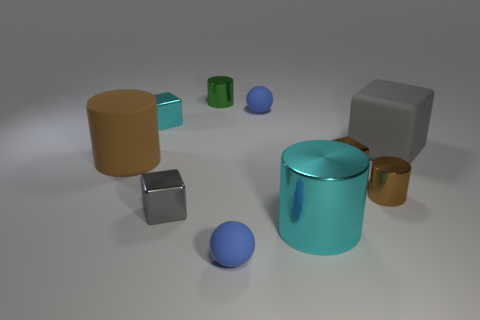What number of small metal cylinders have the same color as the big block?
Keep it short and to the point. 0. How many objects are tiny blue matte balls in front of the big brown matte thing or rubber balls that are in front of the big gray rubber cube?
Make the answer very short. 1. Are there fewer objects behind the big brown matte thing than cylinders?
Give a very brief answer. No. Is there a cyan block that has the same size as the brown block?
Your answer should be very brief. Yes. The large block has what color?
Ensure brevity in your answer.  Gray. Does the cyan cylinder have the same size as the cyan cube?
Provide a succinct answer. No. How many objects are large blocks or small metallic cylinders?
Your answer should be very brief. 3. Are there an equal number of small blue matte things that are left of the green metal thing and large red matte cubes?
Your answer should be compact. Yes. There is a big cylinder that is on the right side of the tiny object that is in front of the big cyan metallic thing; is there a rubber thing that is right of it?
Give a very brief answer. Yes. What color is the big cylinder that is made of the same material as the small brown cylinder?
Offer a very short reply. Cyan. 